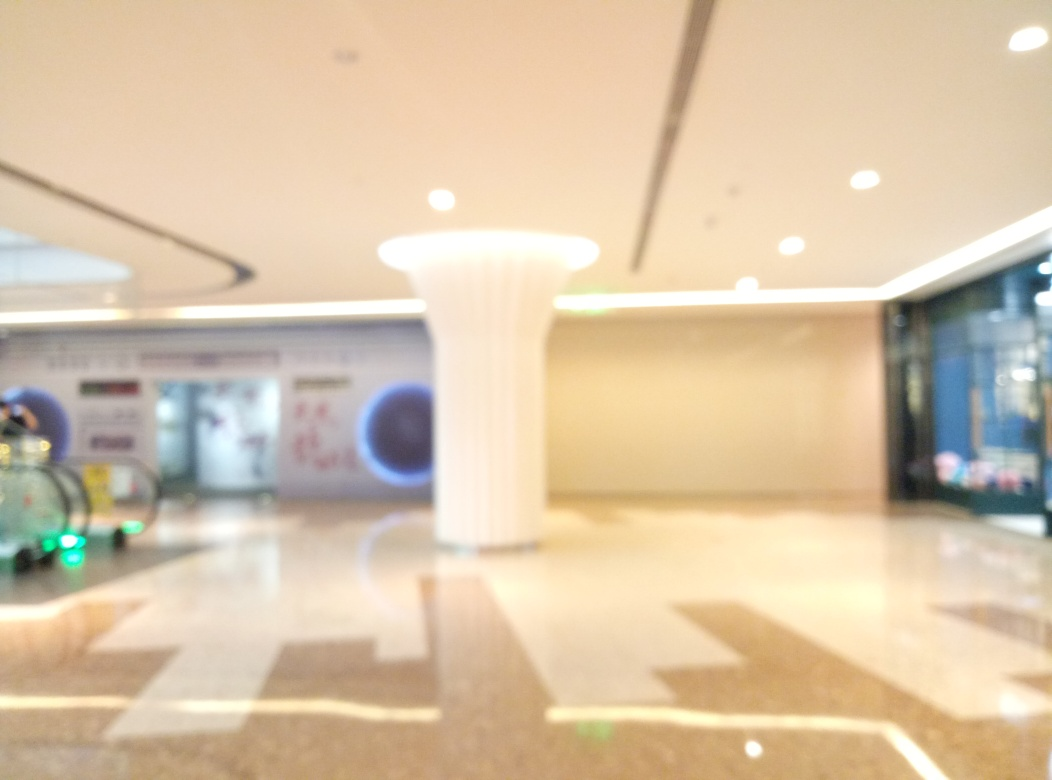What kind of location is depicted in this image? The image shows an indoor space, likely a public area such as a lobby or a mall, characterized by what appears to be a polished floor, a column, and visible store entrances. The lighting suggests an interior space, and the design elements indicate it could be a modern and possibly upscale location. 